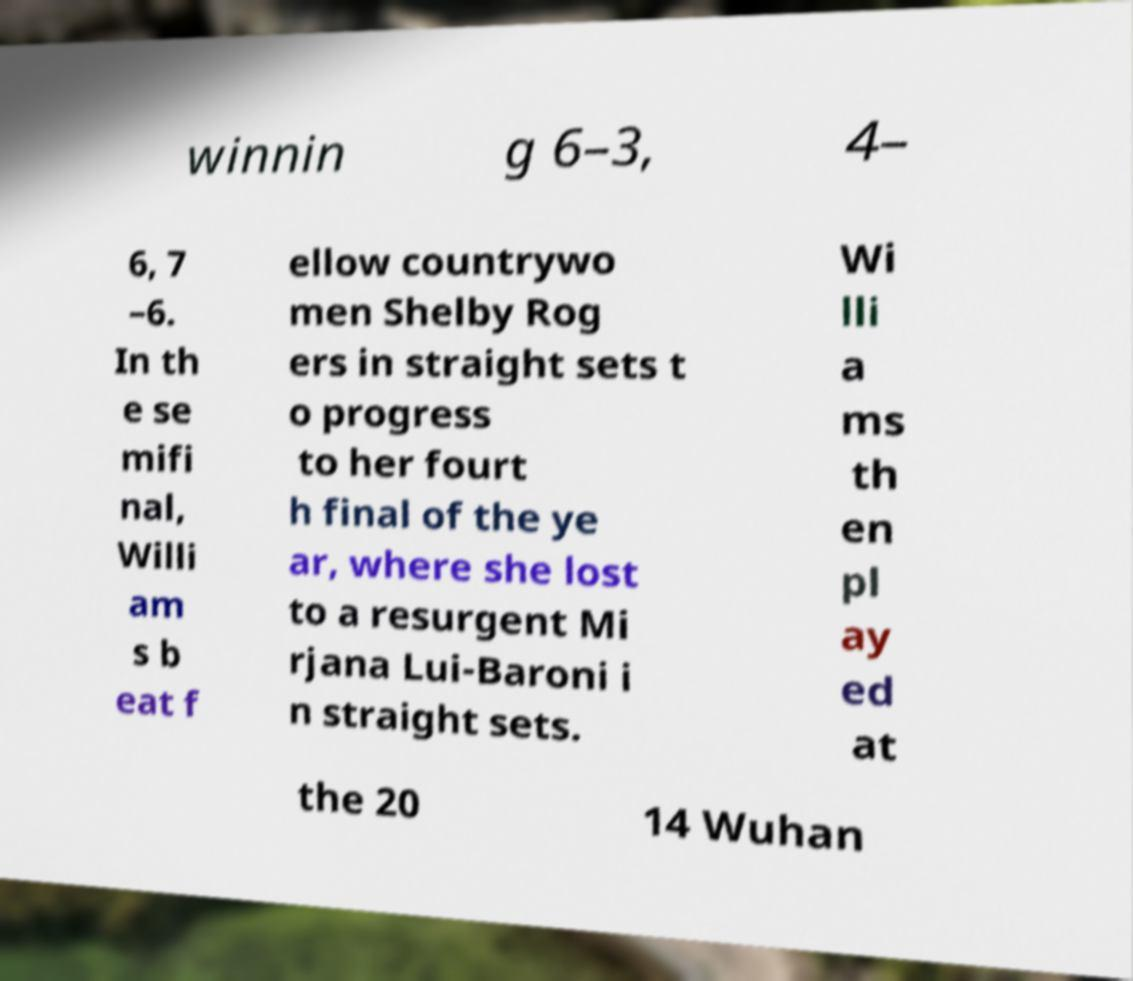What messages or text are displayed in this image? I need them in a readable, typed format. winnin g 6–3, 4– 6, 7 –6. In th e se mifi nal, Willi am s b eat f ellow countrywo men Shelby Rog ers in straight sets t o progress to her fourt h final of the ye ar, where she lost to a resurgent Mi rjana Lui-Baroni i n straight sets. Wi lli a ms th en pl ay ed at the 20 14 Wuhan 